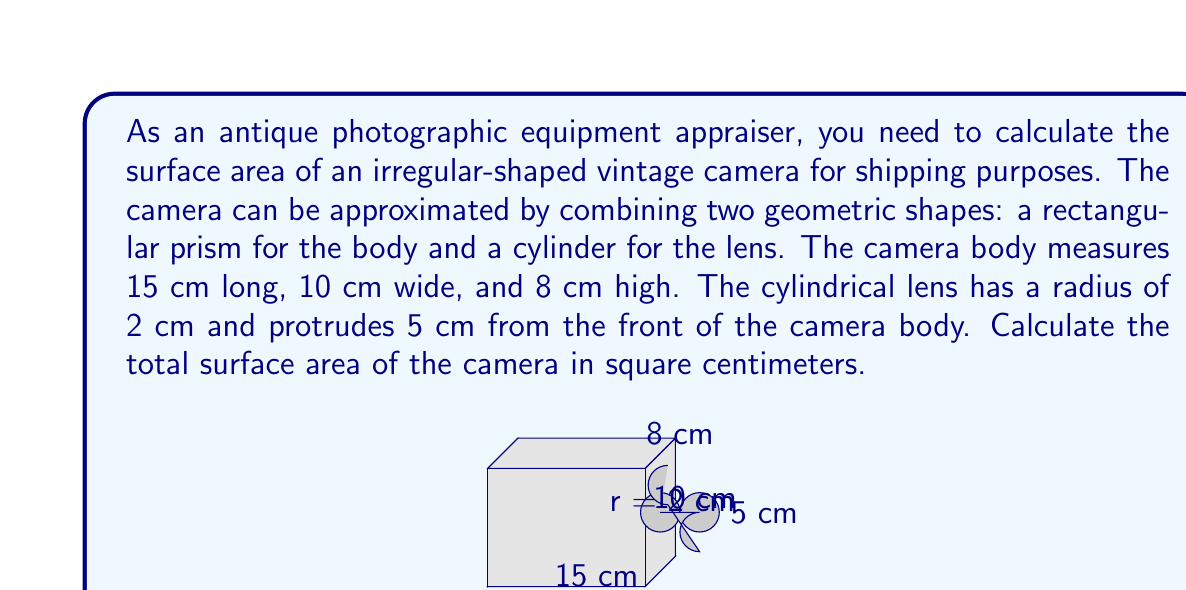Help me with this question. To calculate the total surface area of the camera, we need to find the surface area of the rectangular prism (camera body) and the cylinder (lens), then add them together.

1. Surface area of the rectangular prism (camera body):
   $$A_{prism} = 2(lw + lh + wh)$$
   where $l$ = length, $w$ = width, and $h$ = height
   $$A_{prism} = 2[(15 \times 10) + (15 \times 8) + (10 \times 8)]$$
   $$A_{prism} = 2(150 + 120 + 80) = 2(350) = 700 \text{ cm}^2$$

2. Surface area of the cylinder (lens):
   $$A_{cylinder} = 2\pi r^2 + 2\pi rh$$
   where $r$ = radius and $h$ = height
   $$A_{cylinder} = 2\pi(2)^2 + 2\pi(2)(5)$$
   $$A_{cylinder} = 8\pi + 20\pi = 28\pi \approx 87.96 \text{ cm}^2$$

3. We need to subtract the area of the circular face where the lens meets the camera body:
   $$A_{circle} = \pi r^2 = \pi(2)^2 = 4\pi \approx 12.57 \text{ cm}^2$$

4. Total surface area:
   $$A_{total} = A_{prism} + A_{cylinder} - A_{circle}$$
   $$A_{total} = 700 + 87.96 - 12.57 = 775.39 \text{ cm}^2$$

Therefore, the total surface area of the vintage camera is approximately 775.39 square centimeters.
Answer: $775.39 \text{ cm}^2$ 